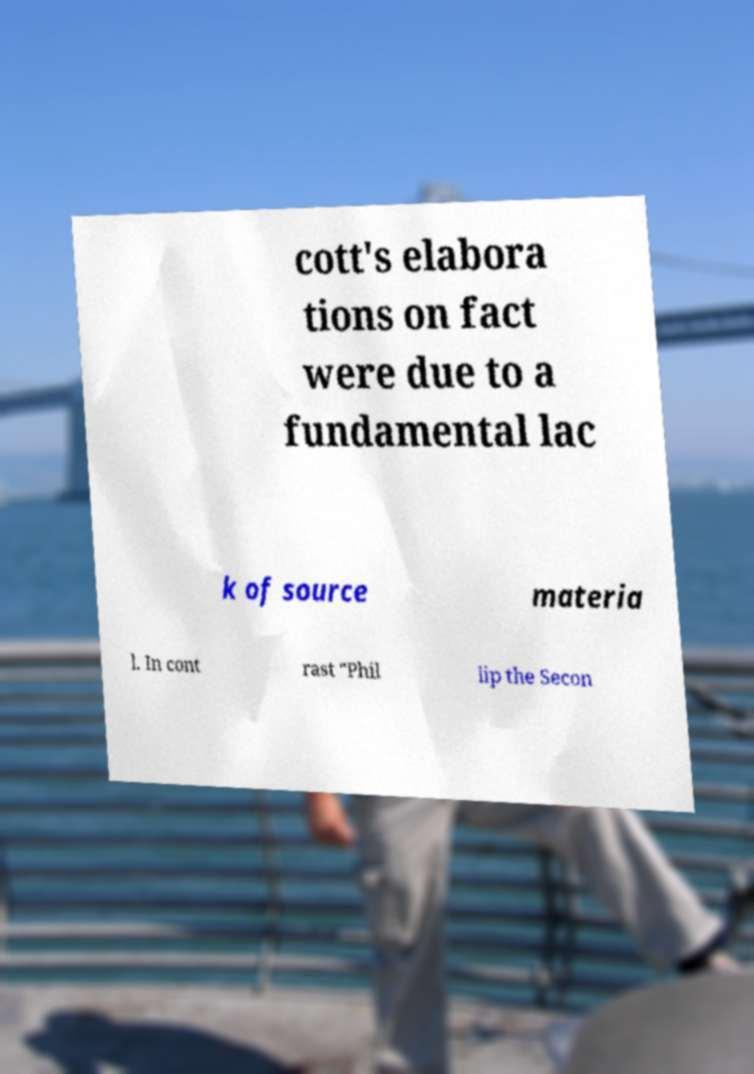I need the written content from this picture converted into text. Can you do that? cott's elabora tions on fact were due to a fundamental lac k of source materia l. In cont rast "Phil lip the Secon 